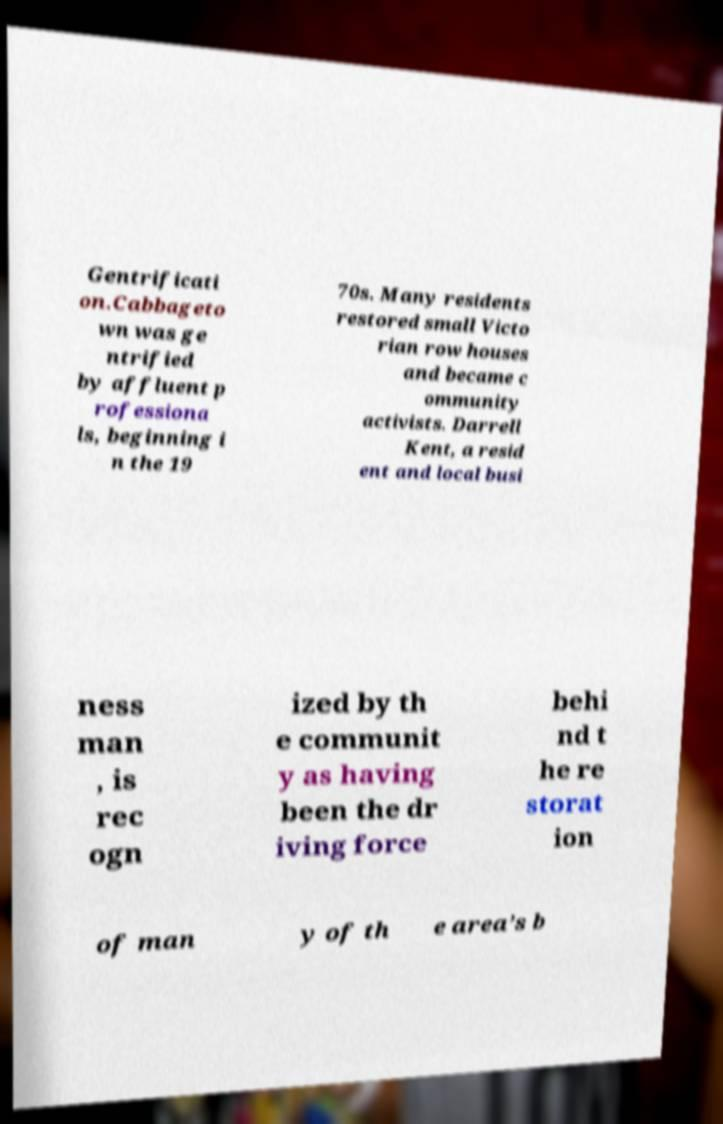I need the written content from this picture converted into text. Can you do that? Gentrificati on.Cabbageto wn was ge ntrified by affluent p rofessiona ls, beginning i n the 19 70s. Many residents restored small Victo rian row houses and became c ommunity activists. Darrell Kent, a resid ent and local busi ness man , is rec ogn ized by th e communit y as having been the dr iving force behi nd t he re storat ion of man y of th e area’s b 